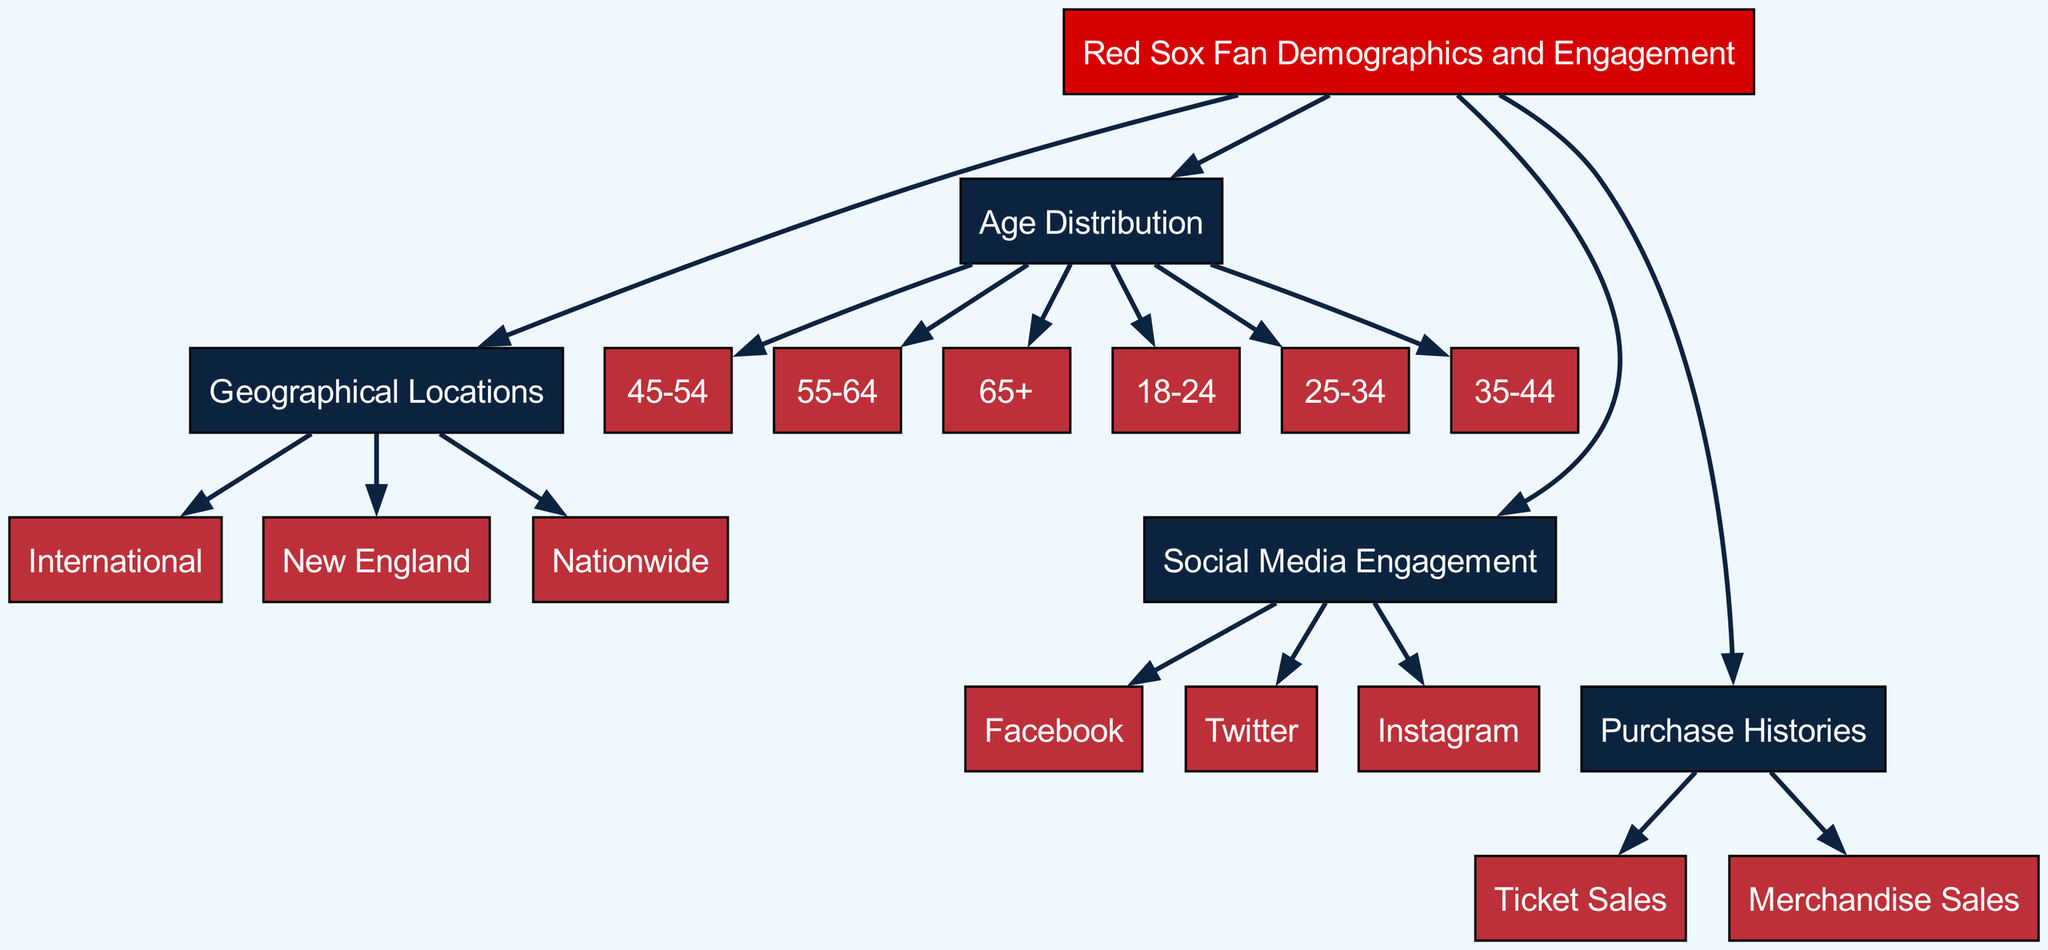What is the main topic of the diagram? The main topic is illustrated by the root node labeled "Red Sox Fan Demographics and Engagement," which serves as the central theme of the diagram.
Answer: Red Sox Fan Demographics and Engagement How many age groups are represented in the diagram? By counting the nodes connected to the "age_distribution" node, we find six distinct age groups: 18-24, 25-34, 35-44, 45-54, 55-64, and 65+.
Answer: 6 Which social media platforms are included in the engagement section? The nodes branching from "social_media_engagement" indicate the platforms Facebook, Twitter, and Instagram, which are explicitly listed and connected to this category.
Answer: Facebook, Twitter, Instagram What geographical area is highlighted as having the most Red Sox fans? The node "New England" is directly linked to "geographical_location," suggesting it is a prominent region for Red Sox fans, even though "nationwide" and "international" are also present.
Answer: New England What type of sales are indicated in the purchase histories? The edges leading from the "purchase_histories" node point to "ticket_sales" and "merchandise_sales," indicating the specific types of sales tracked in the diagram.
Answer: Ticket Sales, Merchandise Sales If a fan is from the international segment, how many main categories does the diagram suggest they fall under? The "international" node is part of the "geographical_location," indicating that it is one of three key geographical categories: New England, Nationwide, and International, which means this segment belongs to one category only.
Answer: 1 Which age distribution category would likely encompass the youngest fans? The "age_18_24" node is directly connected to "age_distribution" and represents the youngest age group, making it the category for the youngest fans.
Answer: 18-24 Which engagement method is not represented in the diagram? The node connections do not include YouTube as a social media engagement method, as the diagram only lists Facebook, Twitter, and Instagram.
Answer: YouTube 